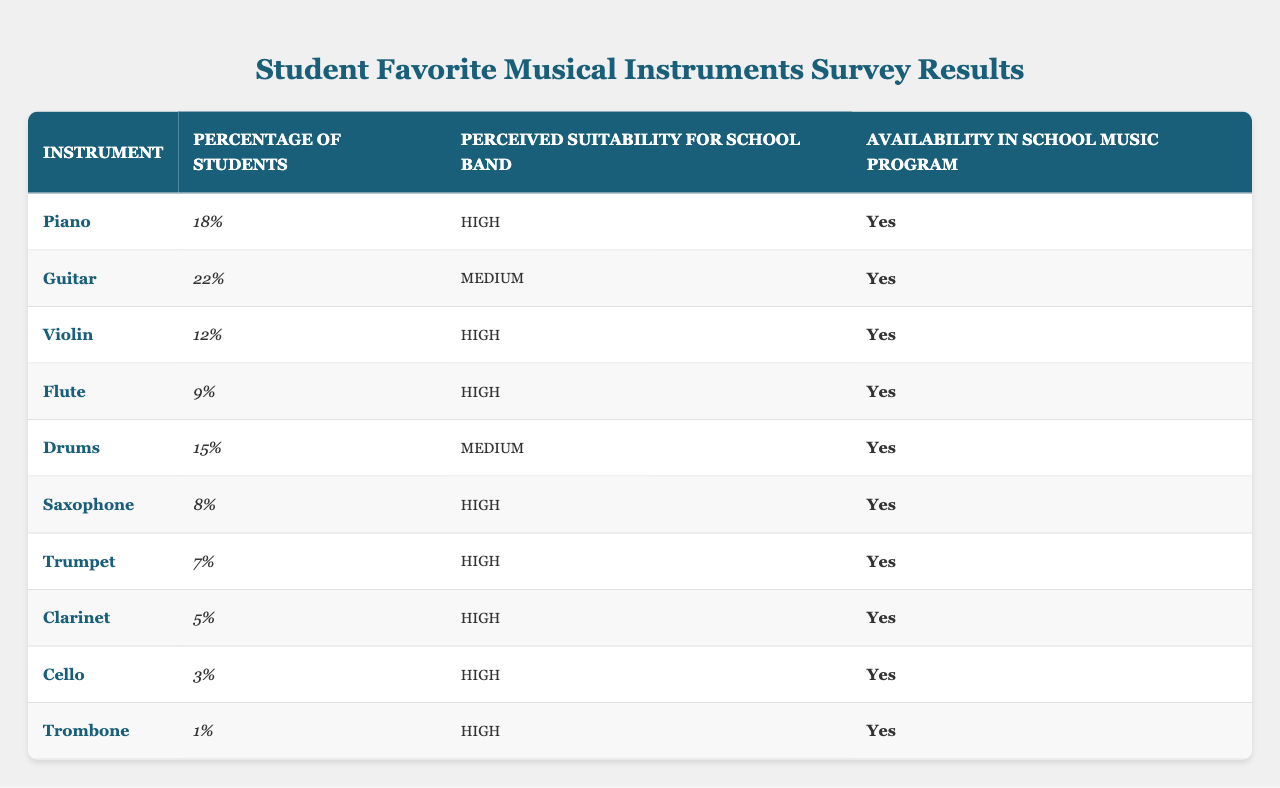What is the percentage of students who prefer the piano? The data shows that the percentage of students who prefer the piano is listed under the "Percentage of Students" column for piano, which is 18%.
Answer: 18% Which instrument has the lowest percentage of student preference? By reviewing the "Percentage of Students" column, we see that the trombone has the lowest percentage at 1%.
Answer: Trombone Is the guitar considered suitable for the school band? The perceived suitability for the guitar is listed as "Medium", which indicates that it is suitable for the school band.
Answer: Yes How many instruments are perceived as having high suitability for the school band? Counting the instruments with "High" in the "Perceived Suitability for School Band" column, we find there are 6 instruments: Piano, Violin, Flute, Saxophone, Trumpet, and Clarinet.
Answer: 6 What is the average percentage of students' preference for all instruments listed? Adding the percentages, we have 18 + 22 + 12 + 9 + 15 + 8 + 7 + 5 + 3 + 1 = 100, and dividing by the number of instruments (10), the average is 100/10 = 10%.
Answer: 10% Is the flute available in the school music program? The availability for the flute is indicated as "Yes" in the corresponding column.
Answer: Yes Which instrument has a higher percentage of students preferring it: guitar or drums? The percentage for the guitar is 22%, and the drums is 15%. Comparing these values clearly shows the guitar is preferred by more students.
Answer: Guitar What is the total percentage of students who prefer either the trumpet or saxophone? Adding the percentages: Trumpet (7%) + Saxophone (8%) = 15%. The total percentage of students who prefer either of these instruments is 15%.
Answer: 15% Of the instruments listed, how many have availability in the school music program? All instruments listed show availability as "Yes", totaling 10 instruments.
Answer: 10 Are there any instruments with low suitability for the school band according to the survey results? Examining the "Perceived Suitability for School Band" column, we see that all instruments are rated as either High or Medium, so there are no instruments with low suitability.
Answer: No 